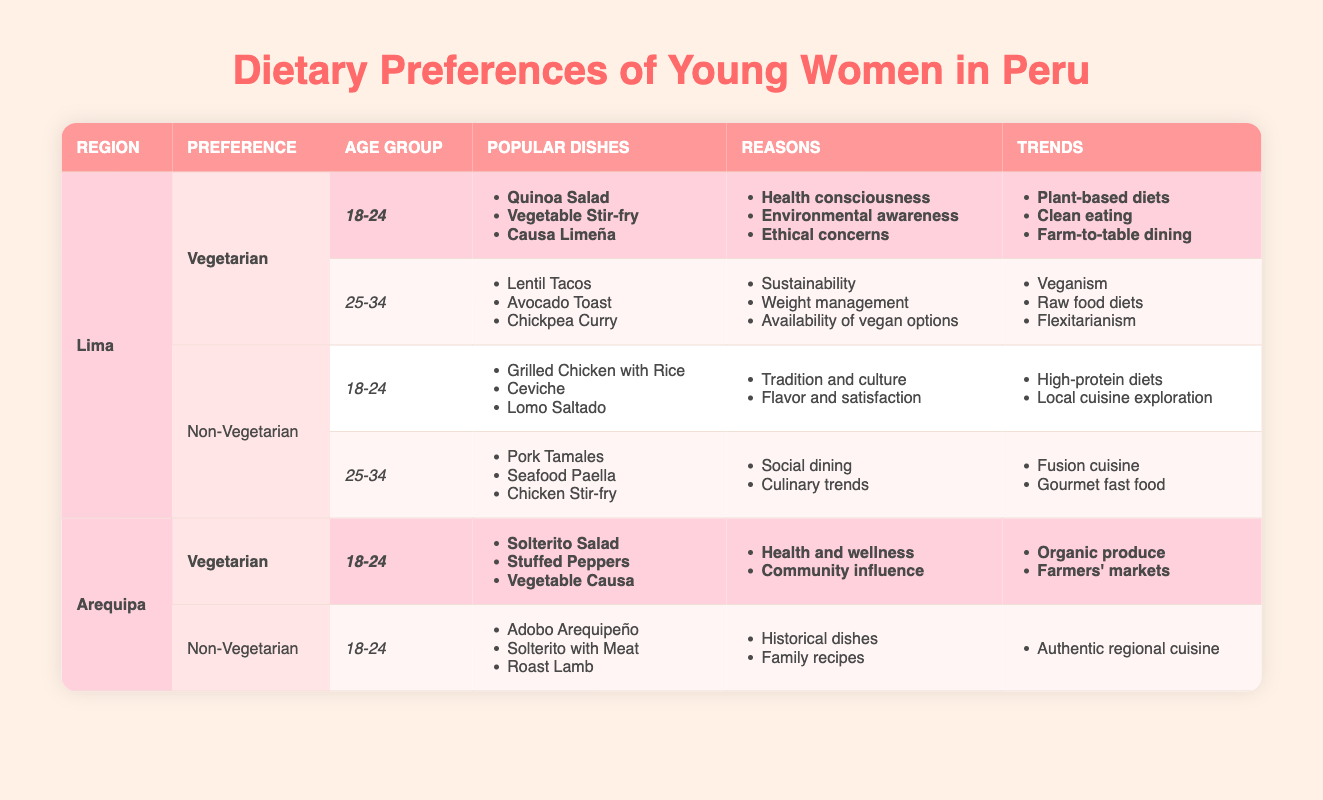What are the popular dishes for vegetarian women aged 18-24 in Lima? According to the table, for vegetarian women aged 18-24 in Lima, the popular dishes include Quinoa Salad, Vegetable Stir-fry, and Causa Limeña.
Answer: Quinoa Salad, Vegetable Stir-fry, Causa Limeña What are the reasons for non-vegetarian preferences for women aged 25-34 in Lima? The reasons for non-vegetarian preferences for women aged 25-34 in Lima include social dining and culinary trends.
Answer: Social dining, culinary trends Is "High-protein diets" a trend among non-vegetarians aged 18-24 in Lima? Yes, "High-protein diets" is listed as a trend for non-vegetarians aged 18-24 in Lima according to the table.
Answer: Yes Which age group in Lima favors vegan dishes more, 18-24 or 25-34? In Lima, the 25-34 age group shows more favor towards vegan dishes, as indicated by the trends like veganism and raw food diets mentioned for that range, compared to the 18-24 age group whose trends focus more on plant-based diets.
Answer: 25-34 How many unique popular dishes are mentioned for non-vegetarian preferences in Arequipa? For non-vegetarian preferences in Arequipa, under the age group 18-24, the popular dishes include Adobo Arequipeño, Solterito with Meat, and Roast Lamb. There are three unique popular dishes mentioned.
Answer: 3 